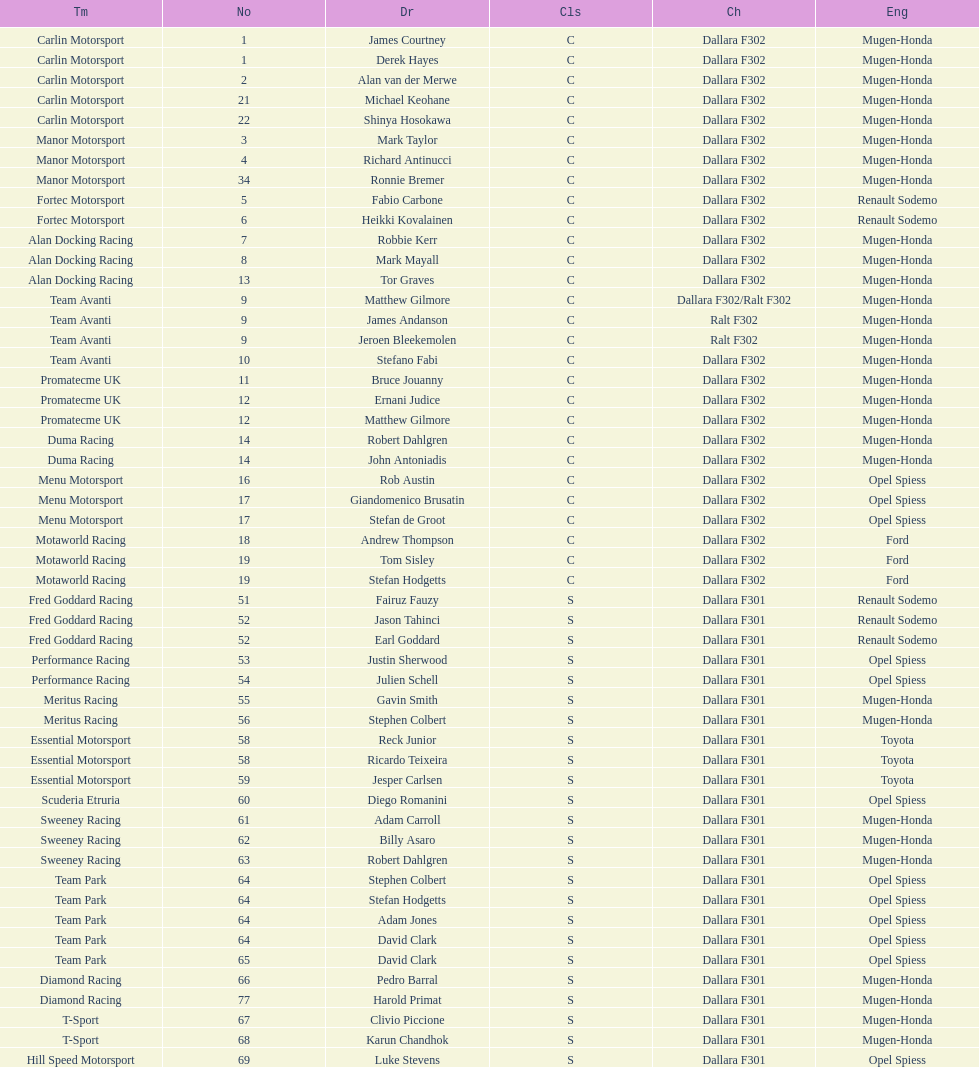How many class s (scholarship) teams are on the chart? 19. 